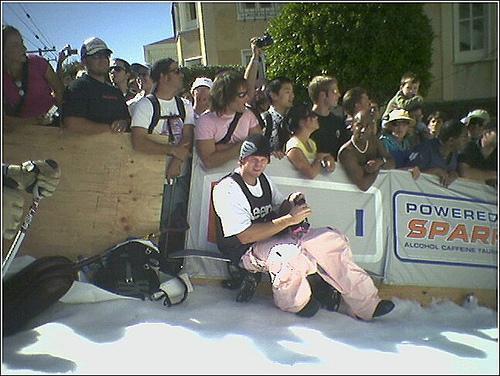How many people can you see?
Give a very brief answer. 8. 